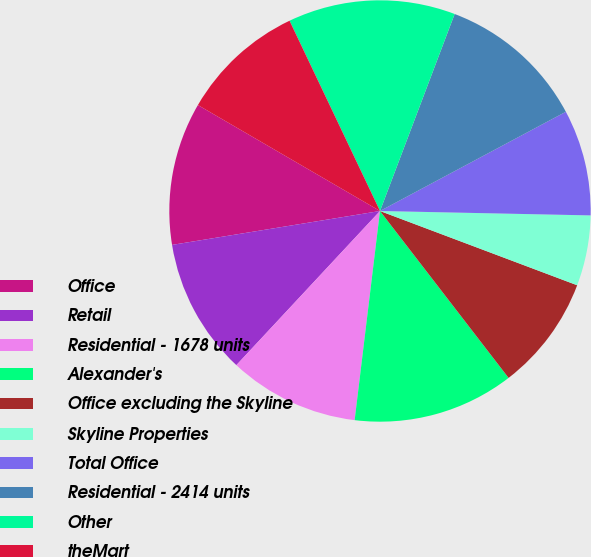<chart> <loc_0><loc_0><loc_500><loc_500><pie_chart><fcel>Office<fcel>Retail<fcel>Residential - 1678 units<fcel>Alexander's<fcel>Office excluding the Skyline<fcel>Skyline Properties<fcel>Total Office<fcel>Residential - 2414 units<fcel>Other<fcel>theMart<nl><fcel>10.96%<fcel>10.49%<fcel>10.02%<fcel>12.37%<fcel>8.82%<fcel>5.4%<fcel>8.14%<fcel>11.43%<fcel>12.83%<fcel>9.55%<nl></chart> 